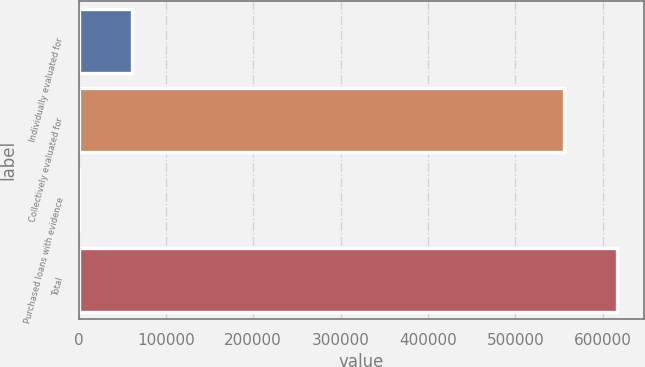<chart> <loc_0><loc_0><loc_500><loc_500><bar_chart><fcel>Individually evaluated for<fcel>Collectively evaluated for<fcel>Purchased loans with evidence<fcel>Total<nl><fcel>61455.3<fcel>555578<fcel>945<fcel>616088<nl></chart> 